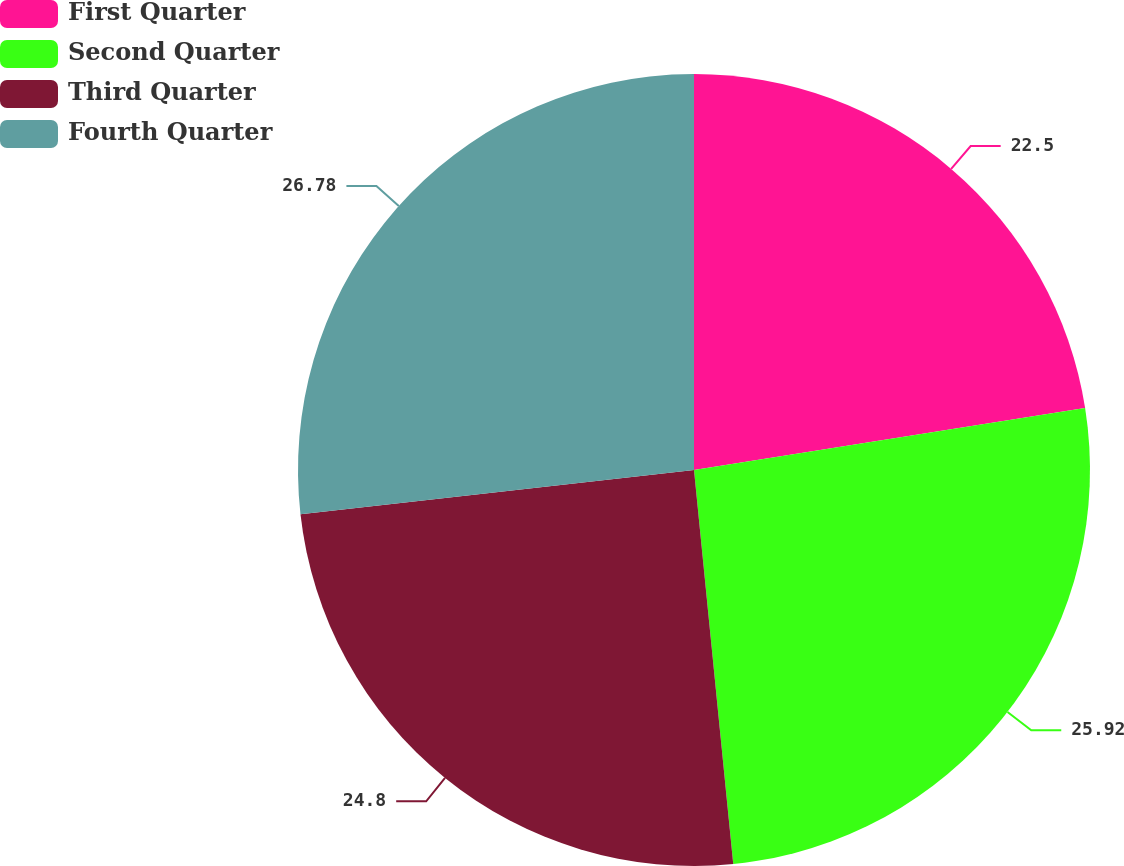Convert chart. <chart><loc_0><loc_0><loc_500><loc_500><pie_chart><fcel>First Quarter<fcel>Second Quarter<fcel>Third Quarter<fcel>Fourth Quarter<nl><fcel>22.5%<fcel>25.92%<fcel>24.8%<fcel>26.78%<nl></chart> 